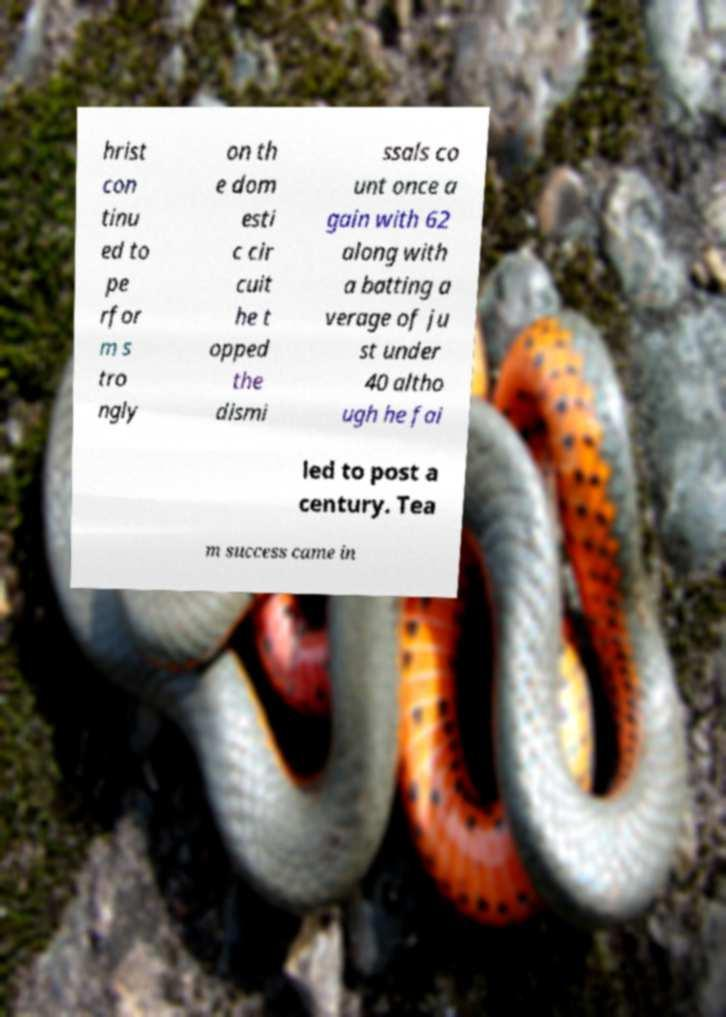Can you accurately transcribe the text from the provided image for me? hrist con tinu ed to pe rfor m s tro ngly on th e dom esti c cir cuit he t opped the dismi ssals co unt once a gain with 62 along with a batting a verage of ju st under 40 altho ugh he fai led to post a century. Tea m success came in 